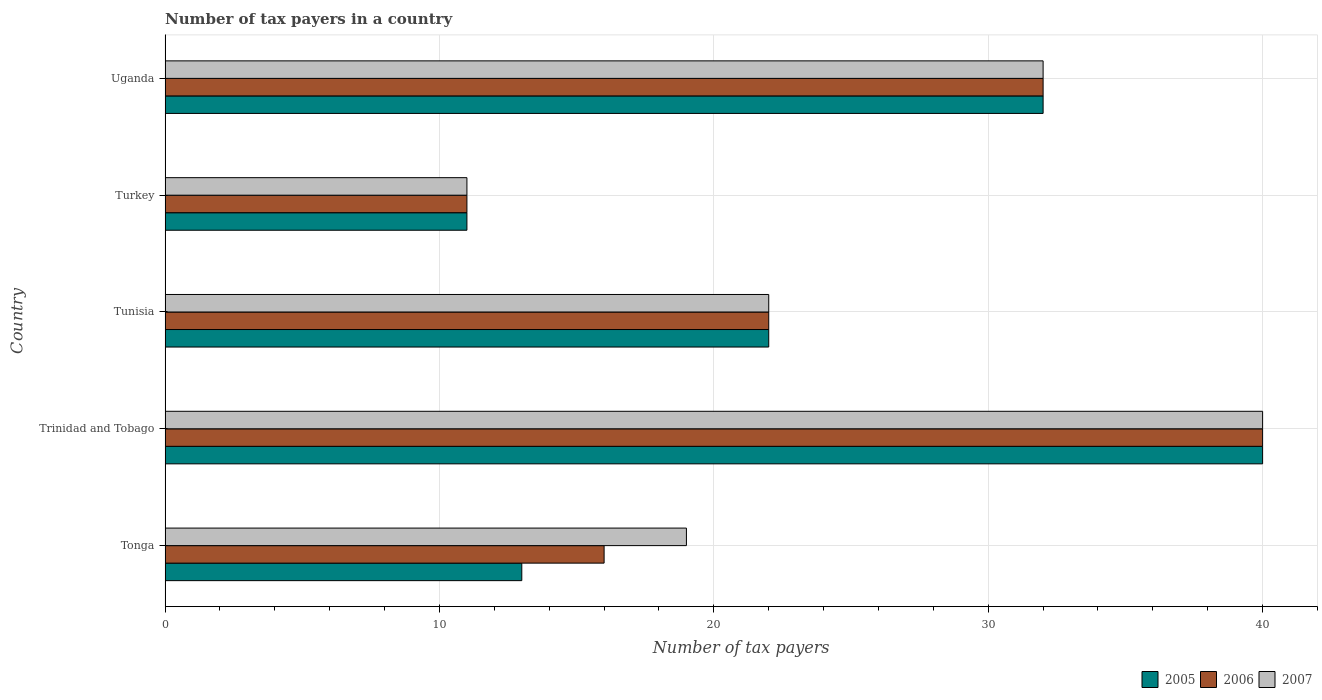How many groups of bars are there?
Offer a very short reply. 5. Are the number of bars per tick equal to the number of legend labels?
Offer a very short reply. Yes. Are the number of bars on each tick of the Y-axis equal?
Ensure brevity in your answer.  Yes. How many bars are there on the 3rd tick from the top?
Ensure brevity in your answer.  3. How many bars are there on the 2nd tick from the bottom?
Offer a terse response. 3. What is the label of the 5th group of bars from the top?
Provide a succinct answer. Tonga. What is the number of tax payers in in 2005 in Trinidad and Tobago?
Ensure brevity in your answer.  40. Across all countries, what is the maximum number of tax payers in in 2006?
Offer a very short reply. 40. In which country was the number of tax payers in in 2006 maximum?
Ensure brevity in your answer.  Trinidad and Tobago. In which country was the number of tax payers in in 2005 minimum?
Make the answer very short. Turkey. What is the total number of tax payers in in 2006 in the graph?
Your answer should be compact. 121. What is the difference between the number of tax payers in in 2006 in Tonga and that in Trinidad and Tobago?
Ensure brevity in your answer.  -24. What is the difference between the number of tax payers in in 2005 in Tonga and the number of tax payers in in 2007 in Turkey?
Offer a very short reply. 2. What is the average number of tax payers in in 2006 per country?
Your answer should be very brief. 24.2. What is the difference between the number of tax payers in in 2006 and number of tax payers in in 2007 in Tonga?
Offer a terse response. -3. What is the ratio of the number of tax payers in in 2006 in Tonga to that in Tunisia?
Provide a succinct answer. 0.73. Is the number of tax payers in in 2006 in Tonga less than that in Trinidad and Tobago?
Your answer should be compact. Yes. Is the difference between the number of tax payers in in 2006 in Tonga and Trinidad and Tobago greater than the difference between the number of tax payers in in 2007 in Tonga and Trinidad and Tobago?
Give a very brief answer. No. What is the difference between the highest and the second highest number of tax payers in in 2007?
Provide a short and direct response. 8. In how many countries, is the number of tax payers in in 2005 greater than the average number of tax payers in in 2005 taken over all countries?
Give a very brief answer. 2. Is the sum of the number of tax payers in in 2007 in Turkey and Uganda greater than the maximum number of tax payers in in 2006 across all countries?
Provide a succinct answer. Yes. What does the 3rd bar from the top in Tonga represents?
Provide a succinct answer. 2005. Is it the case that in every country, the sum of the number of tax payers in in 2006 and number of tax payers in in 2005 is greater than the number of tax payers in in 2007?
Keep it short and to the point. Yes. How many bars are there?
Give a very brief answer. 15. Are all the bars in the graph horizontal?
Offer a very short reply. Yes. What is the difference between two consecutive major ticks on the X-axis?
Make the answer very short. 10. Does the graph contain grids?
Offer a very short reply. Yes. Where does the legend appear in the graph?
Offer a very short reply. Bottom right. How many legend labels are there?
Offer a terse response. 3. What is the title of the graph?
Your answer should be very brief. Number of tax payers in a country. What is the label or title of the X-axis?
Keep it short and to the point. Number of tax payers. What is the Number of tax payers in 2006 in Trinidad and Tobago?
Ensure brevity in your answer.  40. What is the Number of tax payers of 2007 in Trinidad and Tobago?
Offer a terse response. 40. What is the Number of tax payers of 2005 in Tunisia?
Make the answer very short. 22. What is the Number of tax payers of 2007 in Tunisia?
Provide a short and direct response. 22. What is the Number of tax payers in 2005 in Turkey?
Keep it short and to the point. 11. What is the Number of tax payers of 2007 in Turkey?
Ensure brevity in your answer.  11. What is the Number of tax payers in 2005 in Uganda?
Provide a short and direct response. 32. What is the Number of tax payers in 2006 in Uganda?
Offer a terse response. 32. Across all countries, what is the minimum Number of tax payers in 2006?
Give a very brief answer. 11. What is the total Number of tax payers of 2005 in the graph?
Your response must be concise. 118. What is the total Number of tax payers of 2006 in the graph?
Make the answer very short. 121. What is the total Number of tax payers in 2007 in the graph?
Keep it short and to the point. 124. What is the difference between the Number of tax payers in 2005 in Tonga and that in Trinidad and Tobago?
Your answer should be compact. -27. What is the difference between the Number of tax payers in 2006 in Tonga and that in Trinidad and Tobago?
Offer a terse response. -24. What is the difference between the Number of tax payers in 2007 in Tonga and that in Trinidad and Tobago?
Provide a short and direct response. -21. What is the difference between the Number of tax payers of 2005 in Tonga and that in Tunisia?
Your answer should be very brief. -9. What is the difference between the Number of tax payers of 2006 in Tonga and that in Tunisia?
Offer a very short reply. -6. What is the difference between the Number of tax payers in 2007 in Tonga and that in Turkey?
Keep it short and to the point. 8. What is the difference between the Number of tax payers in 2005 in Tonga and that in Uganda?
Keep it short and to the point. -19. What is the difference between the Number of tax payers of 2005 in Trinidad and Tobago and that in Tunisia?
Your response must be concise. 18. What is the difference between the Number of tax payers in 2006 in Trinidad and Tobago and that in Tunisia?
Offer a terse response. 18. What is the difference between the Number of tax payers of 2007 in Trinidad and Tobago and that in Turkey?
Your response must be concise. 29. What is the difference between the Number of tax payers in 2006 in Trinidad and Tobago and that in Uganda?
Make the answer very short. 8. What is the difference between the Number of tax payers in 2006 in Tunisia and that in Turkey?
Ensure brevity in your answer.  11. What is the difference between the Number of tax payers in 2005 in Tunisia and that in Uganda?
Provide a succinct answer. -10. What is the difference between the Number of tax payers in 2005 in Tonga and the Number of tax payers in 2006 in Trinidad and Tobago?
Provide a short and direct response. -27. What is the difference between the Number of tax payers in 2005 in Tonga and the Number of tax payers in 2007 in Trinidad and Tobago?
Offer a terse response. -27. What is the difference between the Number of tax payers of 2005 in Tonga and the Number of tax payers of 2006 in Tunisia?
Ensure brevity in your answer.  -9. What is the difference between the Number of tax payers of 2006 in Tonga and the Number of tax payers of 2007 in Tunisia?
Your response must be concise. -6. What is the difference between the Number of tax payers in 2005 in Tonga and the Number of tax payers in 2006 in Turkey?
Provide a succinct answer. 2. What is the difference between the Number of tax payers of 2005 in Trinidad and Tobago and the Number of tax payers of 2006 in Tunisia?
Your answer should be compact. 18. What is the difference between the Number of tax payers of 2005 in Trinidad and Tobago and the Number of tax payers of 2006 in Turkey?
Your response must be concise. 29. What is the difference between the Number of tax payers in 2006 in Trinidad and Tobago and the Number of tax payers in 2007 in Turkey?
Provide a short and direct response. 29. What is the difference between the Number of tax payers in 2005 in Trinidad and Tobago and the Number of tax payers in 2006 in Uganda?
Ensure brevity in your answer.  8. What is the difference between the Number of tax payers in 2005 in Tunisia and the Number of tax payers in 2007 in Turkey?
Give a very brief answer. 11. What is the difference between the Number of tax payers of 2005 in Tunisia and the Number of tax payers of 2007 in Uganda?
Keep it short and to the point. -10. What is the difference between the Number of tax payers in 2005 in Turkey and the Number of tax payers in 2006 in Uganda?
Offer a very short reply. -21. What is the difference between the Number of tax payers of 2005 in Turkey and the Number of tax payers of 2007 in Uganda?
Ensure brevity in your answer.  -21. What is the average Number of tax payers of 2005 per country?
Keep it short and to the point. 23.6. What is the average Number of tax payers of 2006 per country?
Provide a succinct answer. 24.2. What is the average Number of tax payers of 2007 per country?
Provide a short and direct response. 24.8. What is the difference between the Number of tax payers of 2005 and Number of tax payers of 2007 in Trinidad and Tobago?
Provide a succinct answer. 0. What is the difference between the Number of tax payers of 2005 and Number of tax payers of 2007 in Tunisia?
Provide a short and direct response. 0. What is the difference between the Number of tax payers in 2006 and Number of tax payers in 2007 in Tunisia?
Your answer should be very brief. 0. What is the difference between the Number of tax payers of 2005 and Number of tax payers of 2006 in Turkey?
Offer a terse response. 0. What is the difference between the Number of tax payers of 2006 and Number of tax payers of 2007 in Uganda?
Provide a short and direct response. 0. What is the ratio of the Number of tax payers in 2005 in Tonga to that in Trinidad and Tobago?
Your answer should be very brief. 0.33. What is the ratio of the Number of tax payers of 2006 in Tonga to that in Trinidad and Tobago?
Your answer should be compact. 0.4. What is the ratio of the Number of tax payers of 2007 in Tonga to that in Trinidad and Tobago?
Provide a short and direct response. 0.47. What is the ratio of the Number of tax payers in 2005 in Tonga to that in Tunisia?
Your response must be concise. 0.59. What is the ratio of the Number of tax payers of 2006 in Tonga to that in Tunisia?
Ensure brevity in your answer.  0.73. What is the ratio of the Number of tax payers in 2007 in Tonga to that in Tunisia?
Your answer should be compact. 0.86. What is the ratio of the Number of tax payers in 2005 in Tonga to that in Turkey?
Keep it short and to the point. 1.18. What is the ratio of the Number of tax payers of 2006 in Tonga to that in Turkey?
Ensure brevity in your answer.  1.45. What is the ratio of the Number of tax payers of 2007 in Tonga to that in Turkey?
Your answer should be compact. 1.73. What is the ratio of the Number of tax payers of 2005 in Tonga to that in Uganda?
Keep it short and to the point. 0.41. What is the ratio of the Number of tax payers of 2006 in Tonga to that in Uganda?
Your response must be concise. 0.5. What is the ratio of the Number of tax payers of 2007 in Tonga to that in Uganda?
Keep it short and to the point. 0.59. What is the ratio of the Number of tax payers in 2005 in Trinidad and Tobago to that in Tunisia?
Provide a succinct answer. 1.82. What is the ratio of the Number of tax payers of 2006 in Trinidad and Tobago to that in Tunisia?
Provide a short and direct response. 1.82. What is the ratio of the Number of tax payers in 2007 in Trinidad and Tobago to that in Tunisia?
Ensure brevity in your answer.  1.82. What is the ratio of the Number of tax payers of 2005 in Trinidad and Tobago to that in Turkey?
Provide a succinct answer. 3.64. What is the ratio of the Number of tax payers of 2006 in Trinidad and Tobago to that in Turkey?
Keep it short and to the point. 3.64. What is the ratio of the Number of tax payers in 2007 in Trinidad and Tobago to that in Turkey?
Give a very brief answer. 3.64. What is the ratio of the Number of tax payers of 2005 in Trinidad and Tobago to that in Uganda?
Give a very brief answer. 1.25. What is the ratio of the Number of tax payers in 2006 in Trinidad and Tobago to that in Uganda?
Your answer should be very brief. 1.25. What is the ratio of the Number of tax payers in 2005 in Tunisia to that in Turkey?
Provide a short and direct response. 2. What is the ratio of the Number of tax payers in 2005 in Tunisia to that in Uganda?
Offer a terse response. 0.69. What is the ratio of the Number of tax payers of 2006 in Tunisia to that in Uganda?
Keep it short and to the point. 0.69. What is the ratio of the Number of tax payers in 2007 in Tunisia to that in Uganda?
Give a very brief answer. 0.69. What is the ratio of the Number of tax payers in 2005 in Turkey to that in Uganda?
Offer a terse response. 0.34. What is the ratio of the Number of tax payers of 2006 in Turkey to that in Uganda?
Provide a succinct answer. 0.34. What is the ratio of the Number of tax payers in 2007 in Turkey to that in Uganda?
Ensure brevity in your answer.  0.34. What is the difference between the highest and the second highest Number of tax payers of 2006?
Make the answer very short. 8. What is the difference between the highest and the lowest Number of tax payers in 2007?
Make the answer very short. 29. 